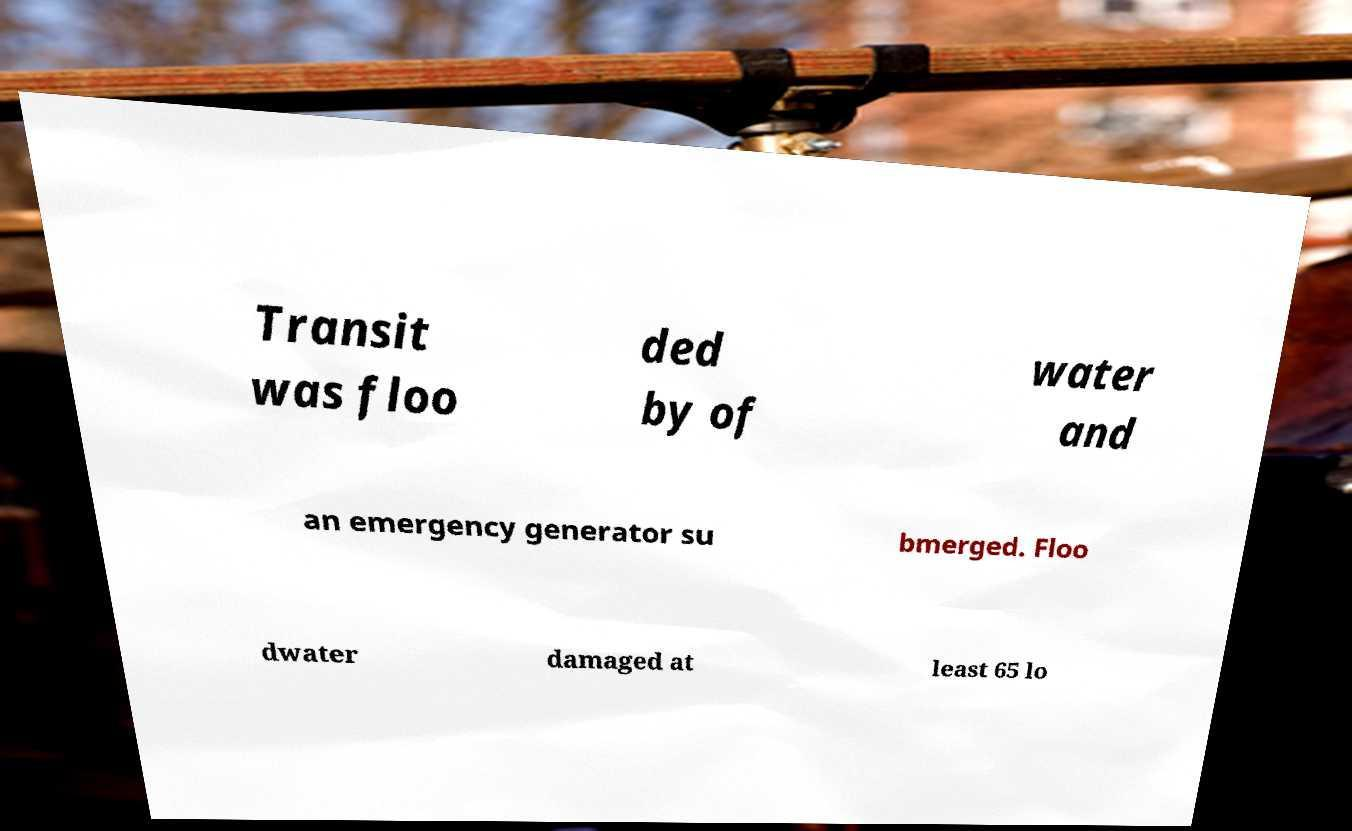I need the written content from this picture converted into text. Can you do that? Transit was floo ded by of water and an emergency generator su bmerged. Floo dwater damaged at least 65 lo 